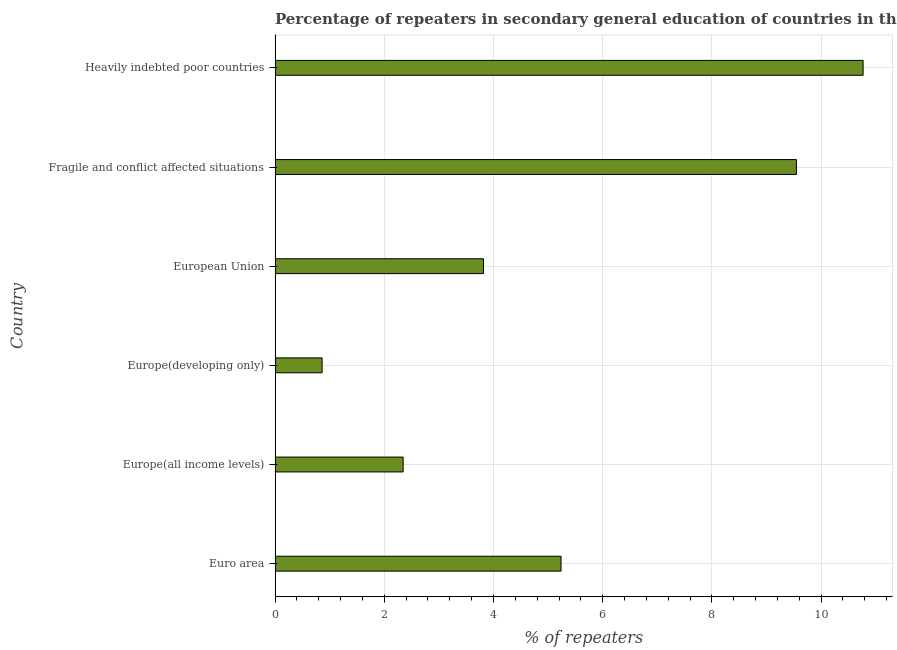Does the graph contain grids?
Your answer should be very brief. Yes. What is the title of the graph?
Your response must be concise. Percentage of repeaters in secondary general education of countries in the year 2009. What is the label or title of the X-axis?
Give a very brief answer. % of repeaters. What is the percentage of repeaters in Euro area?
Offer a very short reply. 5.24. Across all countries, what is the maximum percentage of repeaters?
Provide a succinct answer. 10.77. Across all countries, what is the minimum percentage of repeaters?
Offer a terse response. 0.86. In which country was the percentage of repeaters maximum?
Your answer should be compact. Heavily indebted poor countries. In which country was the percentage of repeaters minimum?
Your response must be concise. Europe(developing only). What is the sum of the percentage of repeaters?
Offer a very short reply. 32.58. What is the difference between the percentage of repeaters in Euro area and European Union?
Your response must be concise. 1.42. What is the average percentage of repeaters per country?
Your answer should be very brief. 5.43. What is the median percentage of repeaters?
Keep it short and to the point. 4.53. In how many countries, is the percentage of repeaters greater than 4.8 %?
Ensure brevity in your answer.  3. What is the ratio of the percentage of repeaters in Fragile and conflict affected situations to that in Heavily indebted poor countries?
Your answer should be very brief. 0.89. What is the difference between the highest and the second highest percentage of repeaters?
Your answer should be compact. 1.22. What is the difference between the highest and the lowest percentage of repeaters?
Provide a succinct answer. 9.91. In how many countries, is the percentage of repeaters greater than the average percentage of repeaters taken over all countries?
Your response must be concise. 2. How many bars are there?
Offer a terse response. 6. What is the difference between two consecutive major ticks on the X-axis?
Offer a terse response. 2. Are the values on the major ticks of X-axis written in scientific E-notation?
Ensure brevity in your answer.  No. What is the % of repeaters of Euro area?
Your answer should be compact. 5.24. What is the % of repeaters in Europe(all income levels)?
Give a very brief answer. 2.35. What is the % of repeaters of Europe(developing only)?
Your answer should be compact. 0.86. What is the % of repeaters of European Union?
Make the answer very short. 3.82. What is the % of repeaters of Fragile and conflict affected situations?
Make the answer very short. 9.55. What is the % of repeaters in Heavily indebted poor countries?
Make the answer very short. 10.77. What is the difference between the % of repeaters in Euro area and Europe(all income levels)?
Your response must be concise. 2.89. What is the difference between the % of repeaters in Euro area and Europe(developing only)?
Offer a terse response. 4.38. What is the difference between the % of repeaters in Euro area and European Union?
Offer a very short reply. 1.42. What is the difference between the % of repeaters in Euro area and Fragile and conflict affected situations?
Make the answer very short. -4.31. What is the difference between the % of repeaters in Euro area and Heavily indebted poor countries?
Give a very brief answer. -5.53. What is the difference between the % of repeaters in Europe(all income levels) and Europe(developing only)?
Your response must be concise. 1.48. What is the difference between the % of repeaters in Europe(all income levels) and European Union?
Keep it short and to the point. -1.47. What is the difference between the % of repeaters in Europe(all income levels) and Fragile and conflict affected situations?
Keep it short and to the point. -7.2. What is the difference between the % of repeaters in Europe(all income levels) and Heavily indebted poor countries?
Ensure brevity in your answer.  -8.42. What is the difference between the % of repeaters in Europe(developing only) and European Union?
Make the answer very short. -2.95. What is the difference between the % of repeaters in Europe(developing only) and Fragile and conflict affected situations?
Give a very brief answer. -8.69. What is the difference between the % of repeaters in Europe(developing only) and Heavily indebted poor countries?
Offer a very short reply. -9.91. What is the difference between the % of repeaters in European Union and Fragile and conflict affected situations?
Keep it short and to the point. -5.73. What is the difference between the % of repeaters in European Union and Heavily indebted poor countries?
Offer a very short reply. -6.95. What is the difference between the % of repeaters in Fragile and conflict affected situations and Heavily indebted poor countries?
Provide a short and direct response. -1.22. What is the ratio of the % of repeaters in Euro area to that in Europe(all income levels)?
Provide a succinct answer. 2.23. What is the ratio of the % of repeaters in Euro area to that in Europe(developing only)?
Keep it short and to the point. 6.08. What is the ratio of the % of repeaters in Euro area to that in European Union?
Make the answer very short. 1.37. What is the ratio of the % of repeaters in Euro area to that in Fragile and conflict affected situations?
Keep it short and to the point. 0.55. What is the ratio of the % of repeaters in Euro area to that in Heavily indebted poor countries?
Your response must be concise. 0.49. What is the ratio of the % of repeaters in Europe(all income levels) to that in Europe(developing only)?
Offer a very short reply. 2.72. What is the ratio of the % of repeaters in Europe(all income levels) to that in European Union?
Your answer should be very brief. 0.61. What is the ratio of the % of repeaters in Europe(all income levels) to that in Fragile and conflict affected situations?
Make the answer very short. 0.25. What is the ratio of the % of repeaters in Europe(all income levels) to that in Heavily indebted poor countries?
Offer a terse response. 0.22. What is the ratio of the % of repeaters in Europe(developing only) to that in European Union?
Provide a succinct answer. 0.23. What is the ratio of the % of repeaters in Europe(developing only) to that in Fragile and conflict affected situations?
Provide a short and direct response. 0.09. What is the ratio of the % of repeaters in Europe(developing only) to that in Heavily indebted poor countries?
Give a very brief answer. 0.08. What is the ratio of the % of repeaters in European Union to that in Fragile and conflict affected situations?
Keep it short and to the point. 0.4. What is the ratio of the % of repeaters in European Union to that in Heavily indebted poor countries?
Your answer should be compact. 0.35. What is the ratio of the % of repeaters in Fragile and conflict affected situations to that in Heavily indebted poor countries?
Ensure brevity in your answer.  0.89. 